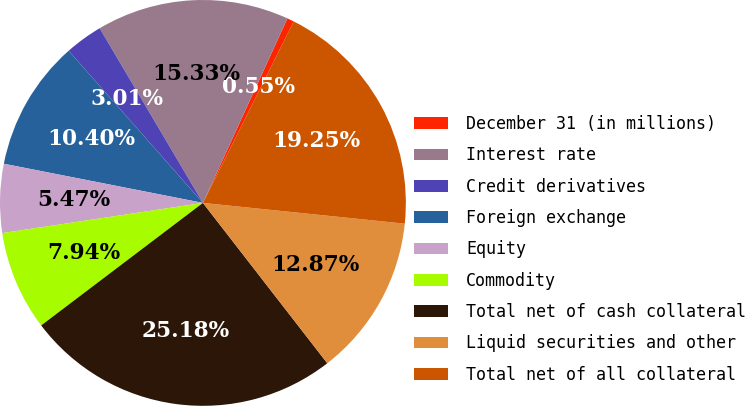Convert chart to OTSL. <chart><loc_0><loc_0><loc_500><loc_500><pie_chart><fcel>December 31 (in millions)<fcel>Interest rate<fcel>Credit derivatives<fcel>Foreign exchange<fcel>Equity<fcel>Commodity<fcel>Total net of cash collateral<fcel>Liquid securities and other<fcel>Total net of all collateral<nl><fcel>0.55%<fcel>15.33%<fcel>3.01%<fcel>10.4%<fcel>5.47%<fcel>7.94%<fcel>25.18%<fcel>12.87%<fcel>19.25%<nl></chart> 